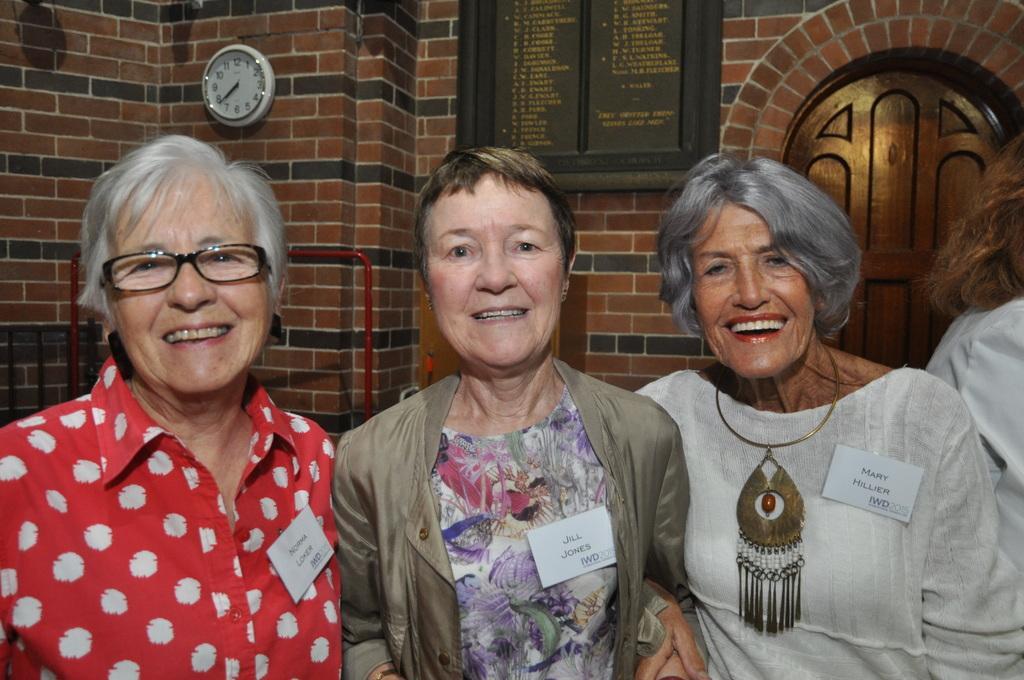How would you summarize this image in a sentence or two? In this picture we can see four people, three people are smiling and name cards on them and in the background we can see a wall, name board, clock and door. 